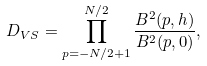<formula> <loc_0><loc_0><loc_500><loc_500>D _ { V S } = \prod _ { p = - N / 2 + 1 } ^ { N / 2 } \frac { B ^ { 2 } ( p , h ) } { B ^ { 2 } ( p , 0 ) } ,</formula> 